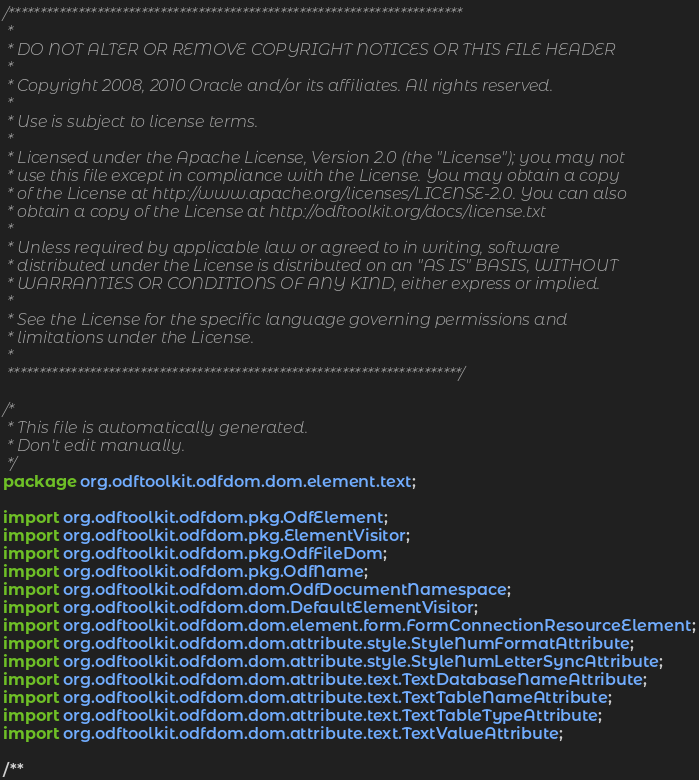Convert code to text. <code><loc_0><loc_0><loc_500><loc_500><_Java_>/************************************************************************
 *
 * DO NOT ALTER OR REMOVE COPYRIGHT NOTICES OR THIS FILE HEADER
 *
 * Copyright 2008, 2010 Oracle and/or its affiliates. All rights reserved.
 *
 * Use is subject to license terms.
 *
 * Licensed under the Apache License, Version 2.0 (the "License"); you may not
 * use this file except in compliance with the License. You may obtain a copy
 * of the License at http://www.apache.org/licenses/LICENSE-2.0. You can also
 * obtain a copy of the License at http://odftoolkit.org/docs/license.txt
 *
 * Unless required by applicable law or agreed to in writing, software
 * distributed under the License is distributed on an "AS IS" BASIS, WITHOUT
 * WARRANTIES OR CONDITIONS OF ANY KIND, either express or implied.
 *
 * See the License for the specific language governing permissions and
 * limitations under the License.
 *
 ************************************************************************/

/*
 * This file is automatically generated.
 * Don't edit manually.
 */
package org.odftoolkit.odfdom.dom.element.text;

import org.odftoolkit.odfdom.pkg.OdfElement;
import org.odftoolkit.odfdom.pkg.ElementVisitor;
import org.odftoolkit.odfdom.pkg.OdfFileDom;
import org.odftoolkit.odfdom.pkg.OdfName;
import org.odftoolkit.odfdom.dom.OdfDocumentNamespace;
import org.odftoolkit.odfdom.dom.DefaultElementVisitor;
import org.odftoolkit.odfdom.dom.element.form.FormConnectionResourceElement;
import org.odftoolkit.odfdom.dom.attribute.style.StyleNumFormatAttribute;
import org.odftoolkit.odfdom.dom.attribute.style.StyleNumLetterSyncAttribute;
import org.odftoolkit.odfdom.dom.attribute.text.TextDatabaseNameAttribute;
import org.odftoolkit.odfdom.dom.attribute.text.TextTableNameAttribute;
import org.odftoolkit.odfdom.dom.attribute.text.TextTableTypeAttribute;
import org.odftoolkit.odfdom.dom.attribute.text.TextValueAttribute;

/**</code> 